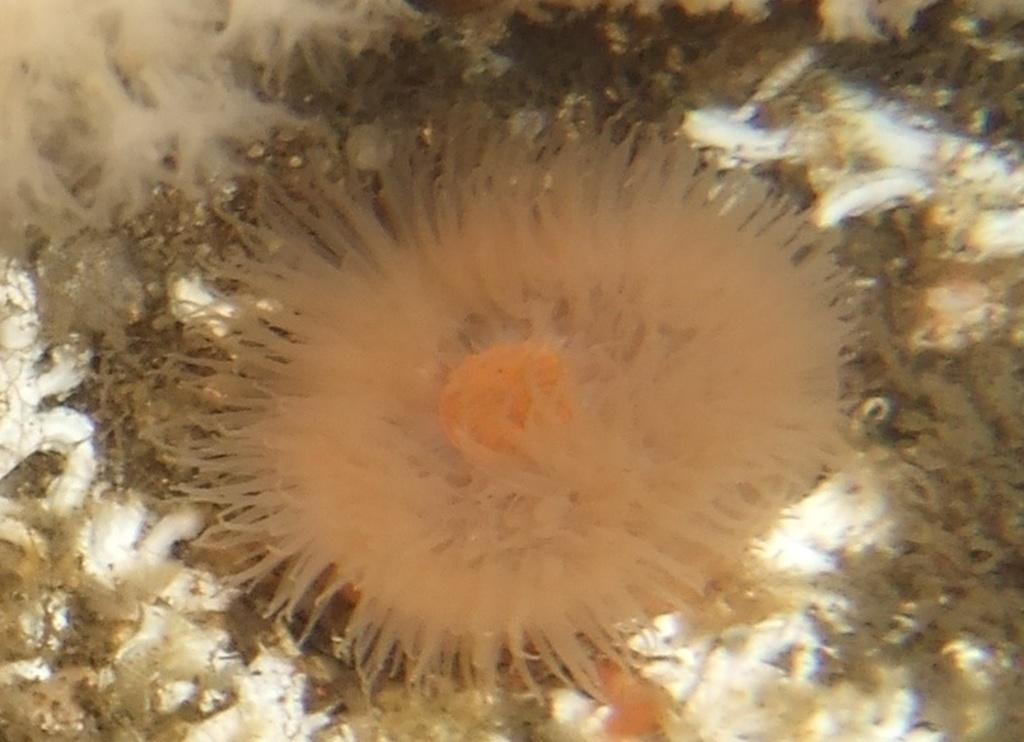Where is the son using the rake in the wilderness? Since there are no facts about the image, we cannot determine if there is a son, a rake, or a wilderness present in the image. 